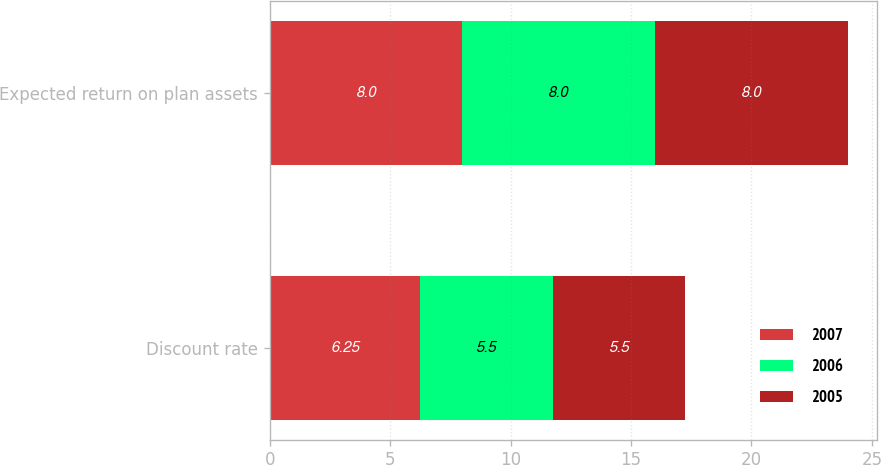Convert chart. <chart><loc_0><loc_0><loc_500><loc_500><stacked_bar_chart><ecel><fcel>Discount rate<fcel>Expected return on plan assets<nl><fcel>2007<fcel>6.25<fcel>8<nl><fcel>2006<fcel>5.5<fcel>8<nl><fcel>2005<fcel>5.5<fcel>8<nl></chart> 